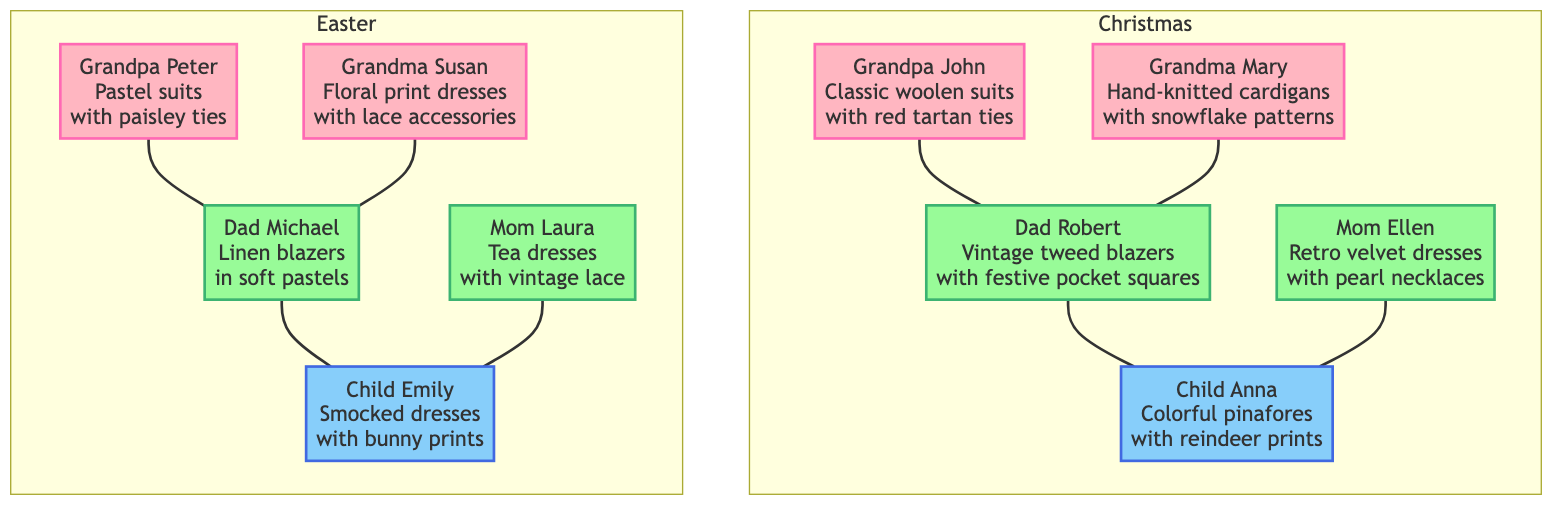What types of outfits did Grandpa John wear for Christmas? According to the diagram, Grandpa John wore "Classic woolen suits with red tartan ties" during Christmas. This is directly found under his node in the Christmas section.
Answer: Classic woolen suits with red tartan ties How many younger generation members are shown for Easter? Observing the diagram, there are two younger generation members listed under the Easter section: Dad Michael and Mom Laura. This information is derived from the "YoungerGenerations" section under Easter.
Answer: 2 What is the color scheme used by Grandma Susan's Easter outfit? The diagram specifies that Grandma Susan wore "Floral print dresses with lace accessories." However, her outfit's color scheme is not explicitly mentioned under her node but could be inferred from the overall Easter section, which includes colors like Light Yellow that may apply to floral prints. Nonetheless, the question strictly asks for the content at her node.
Answer: Floral print dresses with lace accessories Which two colors are part of the traditional Christmas color schemes? The traditional Christmas color schemes listed in the diagram include three colors: Red, Green, and Gold. Thus, picking any two of these fits the criteria of the question.
Answer: Red, Green Who is the youngest member in the family tree? Looking at the diagram, Child Anna and Child Emily are both part of the younger generation, but since Child Anna was mentioned first in the Christmas section and Emily in the Easter section, we identify Child Anna as the youngest member based on order.
Answer: Child Anna What unique item decorates Grandma Mary’s Christmas? The diagram states that Grandma Mary is known for wearing "Hand-knitted cardigans with snowflake patterns." While decor is not specified as "Grandma Mary's," the decor style in Christmas context includes elements like antique Christmas ornaments, which can relate to her snowy theme. The best response derives from her characteristic outfit description.
Answer: Hand-knitted cardigans with snowflake patterns How many total members were included in the Christmas celebration section? Upon reviewing the Christmas section of the diagram, the total members include Grandpa John, Grandma Mary, Dad Robert, Mom Ellen, and Child Anna, amounting to five individuals. Counting all nodes connected directly to the Christmas subgraph confirms this total.
Answer: 5 What patterns are used in the Christmas color scheme? The diagram lists the patterns associated with Christmas, which are Tartan, Fair Isle, and Snowflake. This shows the types of patterns that contribute to the overall festive theme during Christmas festivities.
Answer: Tartan, Fair Isle, Snowflake 